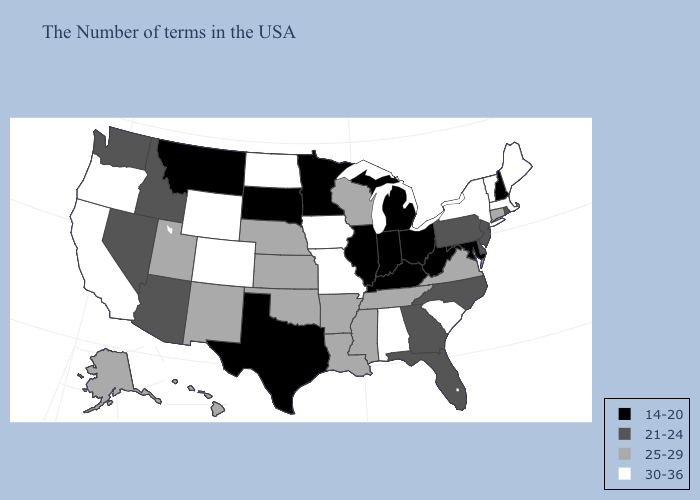What is the value of Arizona?
Quick response, please. 21-24. Among the states that border Virginia , does North Carolina have the lowest value?
Quick response, please. No. Does New Jersey have the highest value in the USA?
Concise answer only. No. Does Kansas have a lower value than New York?
Give a very brief answer. Yes. Does Wyoming have the highest value in the West?
Write a very short answer. Yes. What is the value of Indiana?
Concise answer only. 14-20. What is the value of Oregon?
Give a very brief answer. 30-36. Does Indiana have the highest value in the USA?
Keep it brief. No. Name the states that have a value in the range 14-20?
Write a very short answer. New Hampshire, Maryland, West Virginia, Ohio, Michigan, Kentucky, Indiana, Illinois, Minnesota, Texas, South Dakota, Montana. Name the states that have a value in the range 14-20?
Concise answer only. New Hampshire, Maryland, West Virginia, Ohio, Michigan, Kentucky, Indiana, Illinois, Minnesota, Texas, South Dakota, Montana. Is the legend a continuous bar?
Write a very short answer. No. What is the value of South Dakota?
Quick response, please. 14-20. Name the states that have a value in the range 25-29?
Short answer required. Connecticut, Virginia, Tennessee, Wisconsin, Mississippi, Louisiana, Arkansas, Kansas, Nebraska, Oklahoma, New Mexico, Utah, Alaska, Hawaii. Among the states that border Washington , which have the lowest value?
Be succinct. Idaho. Among the states that border California , which have the lowest value?
Write a very short answer. Arizona, Nevada. 